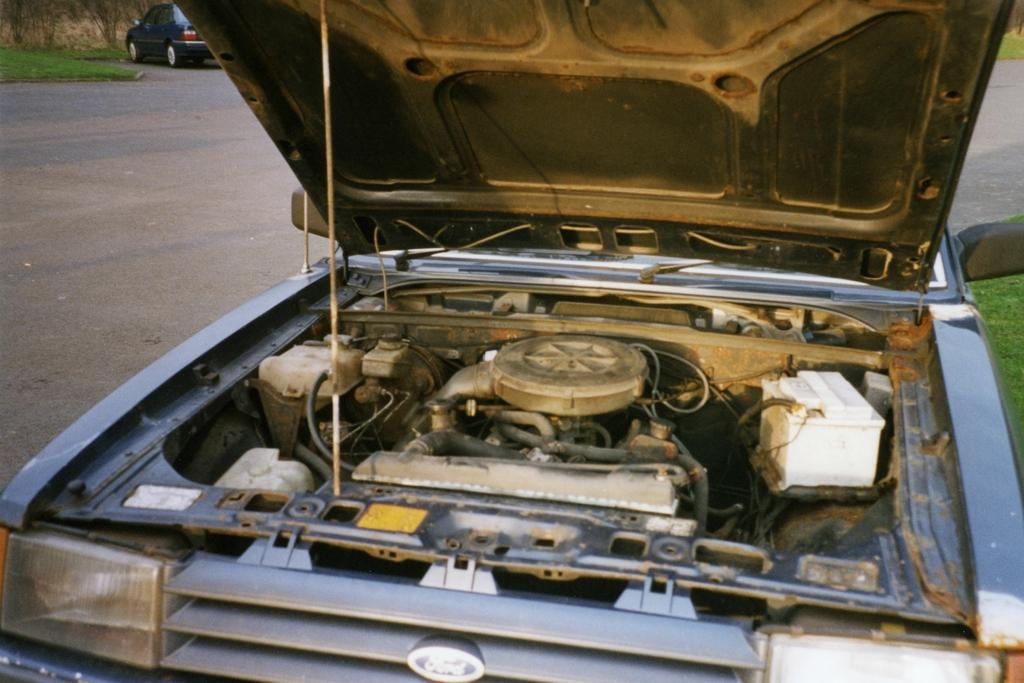What part of a car is the main focus of the image? The engine of a car is the main focus of the image. What are the headlights used for in a car? The headlights are used for illuminating the road while driving. What part of the car is the hood? The hood is the part of the car that covers the engine. Where is the car located in the image? The car is on the road in the image. What type of vegetation can be seen in the image? There is grass visible in the image. What type of iron is being used to create the rail in the image? There is no iron or rail present in the image; it features an engine of a car, headlights, the hood, a car on the road, and grass. 